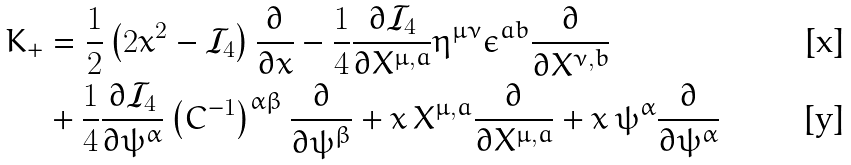<formula> <loc_0><loc_0><loc_500><loc_500>K _ { + } & = \frac { 1 } { 2 } \left ( 2 x ^ { 2 } - \mathcal { I } _ { 4 } \right ) \frac { \partial } { \partial x } - \frac { 1 } { 4 } \frac { \partial \mathcal { I } _ { 4 } } { \partial X ^ { \mu , a } } \eta ^ { \mu \nu } \epsilon ^ { a b } \frac { \partial } { \partial X ^ { \nu , b } } \\ & + \frac { 1 } { 4 } \frac { \partial \mathcal { I } _ { 4 } } { \partial \psi ^ { \alpha } } \left ( C ^ { - 1 } \right ) ^ { \alpha \beta } \frac { \partial } { \partial \psi ^ { \beta } } + x \, X ^ { \mu , a } \frac { \partial } { \partial X ^ { \mu , a } } + x \, \psi ^ { \alpha } \frac { \partial } { \partial \psi ^ { \alpha } }</formula> 